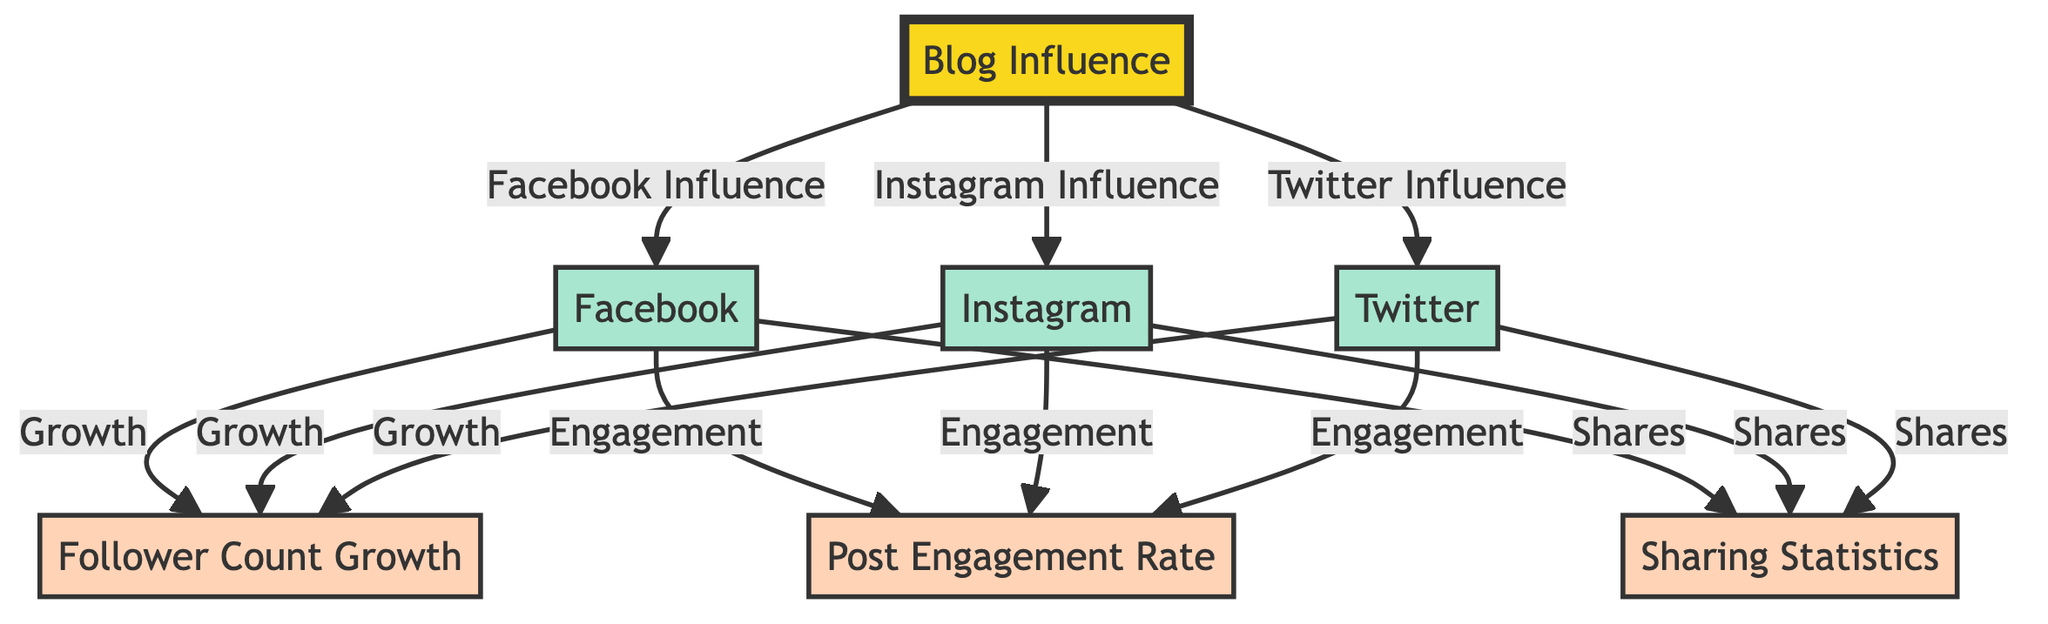What are the three social media platforms represented in the diagram? The diagram specifically highlights three platforms: Facebook, Instagram, and Twitter, each branching out from the central node "Blog Influence."
Answer: Facebook, Instagram, Twitter How many metrics are associated with each platform? Each of the platforms (Facebook, Instagram, Twitter) is associated with three metrics: Follower Count Growth, Post Engagement Rate, and Sharing Statistics. Thus, there are three metrics per platform.
Answer: Three Which social media platform has the most direct connections in the diagram? Each platform connects to three metrics and the central influence node, resulting in a total of four connections per platform. Since all platforms have the same number of connections, they are equal.
Answer: Equal How does post engagement rate relate to Facebook? The diagram shows a direct link from Facebook to the Post Engagement Rate metric, indicating that the engagement level of Facebook posts is an important aspect of its influence.
Answer: Direct link What is the central concept of the diagram? The main idea is encapsulated in the central node labeled "Blog Influence," which serves as the overarching theme from which all social media platforms and their metrics derive.
Answer: Blog Influence If a platform exhibits high follower count growth, what can we infer about its other metrics? While the diagram indicates that follower count growth is a key metric for Facebook, Instagram, and Twitter, it does not explicitly state correlation, making it impossible to definitively infer other metrics just based on follower count growth.
Answer: No direct inference Which metric is associated with sharing statistics for Instagram? The diagram explicitly shows that Sharing Statistics is linked to Instagram, providing insight into how content is disseminated on this platform.
Answer: Sharing Statistics How many total nodes are present in the diagram? Counting the central node ("Blog Influence"), the three social media platforms, and the three metrics for each platform gives us a total count of nine nodes.
Answer: Nine What type of relationship exists between the Blog Influence and Facebook? The relationship is expressed through an arrow indicating that Blog Influence directly influences or relates to Facebook's metrics.
Answer: Direct relationship 